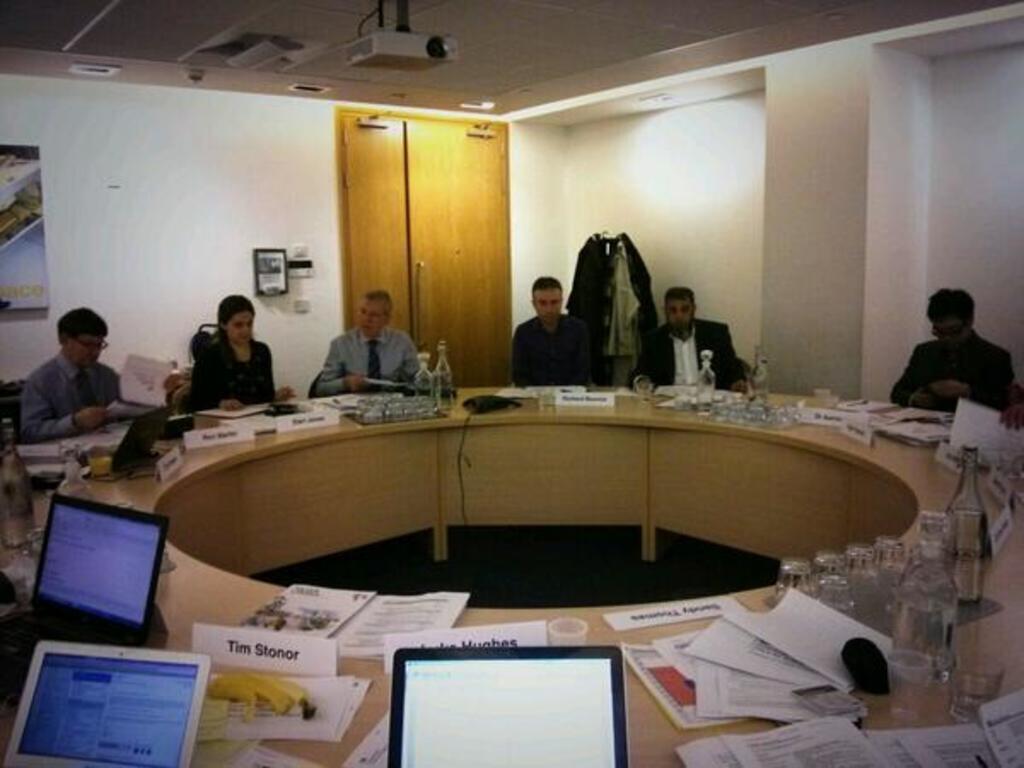Please provide a concise description of this image. In this image I can see few persons are sitting on chairs in front of the cream colored desk and on the desk I can see few bottles, few glasses, few papers, few laptops and few other objects. In the background I can see the white colored wall, the brown colored door, the ceiling, few lights to the ceiling, few objects to the wall and the projector. 